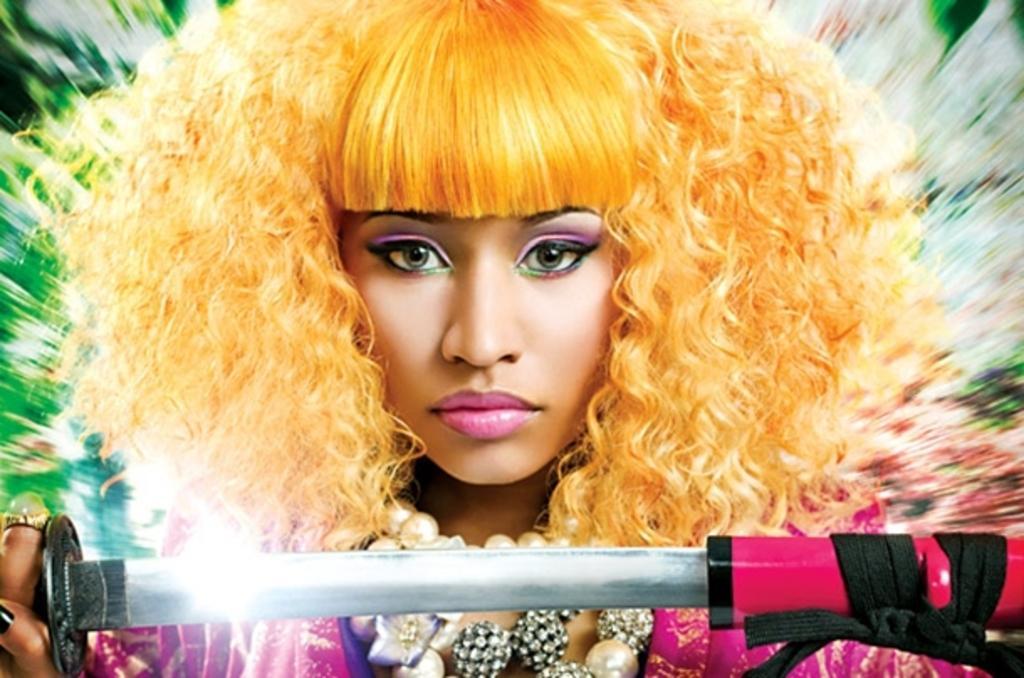In one or two sentences, can you explain what this image depicts? In this image, we can see a woman is holding a weapon and watching. Here we can see blur view. 